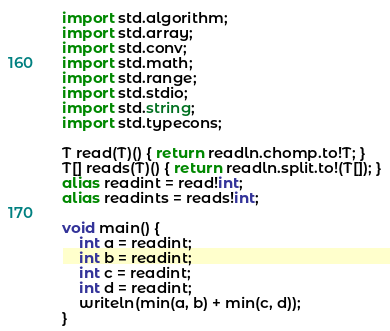<code> <loc_0><loc_0><loc_500><loc_500><_D_>import std.algorithm;
import std.array;
import std.conv;
import std.math;
import std.range;
import std.stdio;
import std.string;
import std.typecons;

T read(T)() { return readln.chomp.to!T; }
T[] reads(T)() { return readln.split.to!(T[]); }
alias readint = read!int;
alias readints = reads!int;

void main() {
    int a = readint;
    int b = readint;
    int c = readint;
    int d = readint;
    writeln(min(a, b) + min(c, d));
}
</code> 